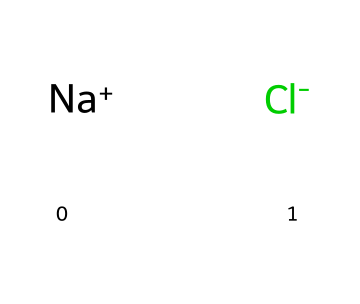What ions are present in this chemical structure? The chemical is represented as [Na+].[Cl-], which indicates the presence of sodium and chloride ions, characterized by their positive and negative charges respectively.
Answer: sodium and chloride How many atoms are present in the chemical structure? The structure consists of one sodium ion (Na+) and one chloride ion (Cl-), totaling two distinct atoms in the structure.
Answer: two What type of chemical bond is present between sodium and chloride? The visualization indicates the presence of ionic charges (Na+ and Cl-), indicating that they are held together by an ionic bond, which forms due to the electrostatic attraction between the oppositely charged ions.
Answer: ionic bond What property allows sodium chloride to be an electrolyte? Sodium chloride dissociates into Na+ and Cl- ions in solution, which allows it to conduct electricity; this property is essential for substances classified as electrolytes.
Answer: conducts electricity Which ion in this structure is positively charged? The chemical representation includes a sodium ion with a positive charge ([Na+]), indicating that this ion carries a positive charge in contrast to the negatively charged chloride ion.
Answer: sodium What is the pH effect of sodium chloride in a solution? Sodium chloride does not significantly affect the pH of a solution because it is a neutral salt, resulting from a strong acid (hydrochloric acid) and a strong base (sodium hydroxide).
Answer: neutral 